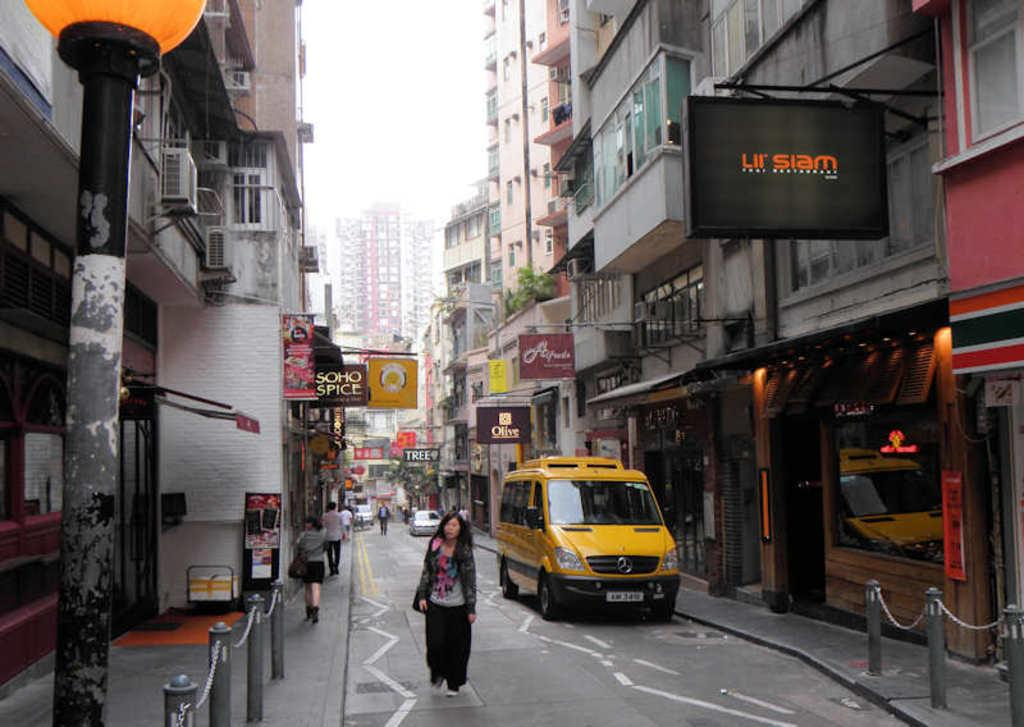<image>
Summarize the visual content of the image. Lil Siam store on the right side with a yellow taxi van and a woman walking on a street. 